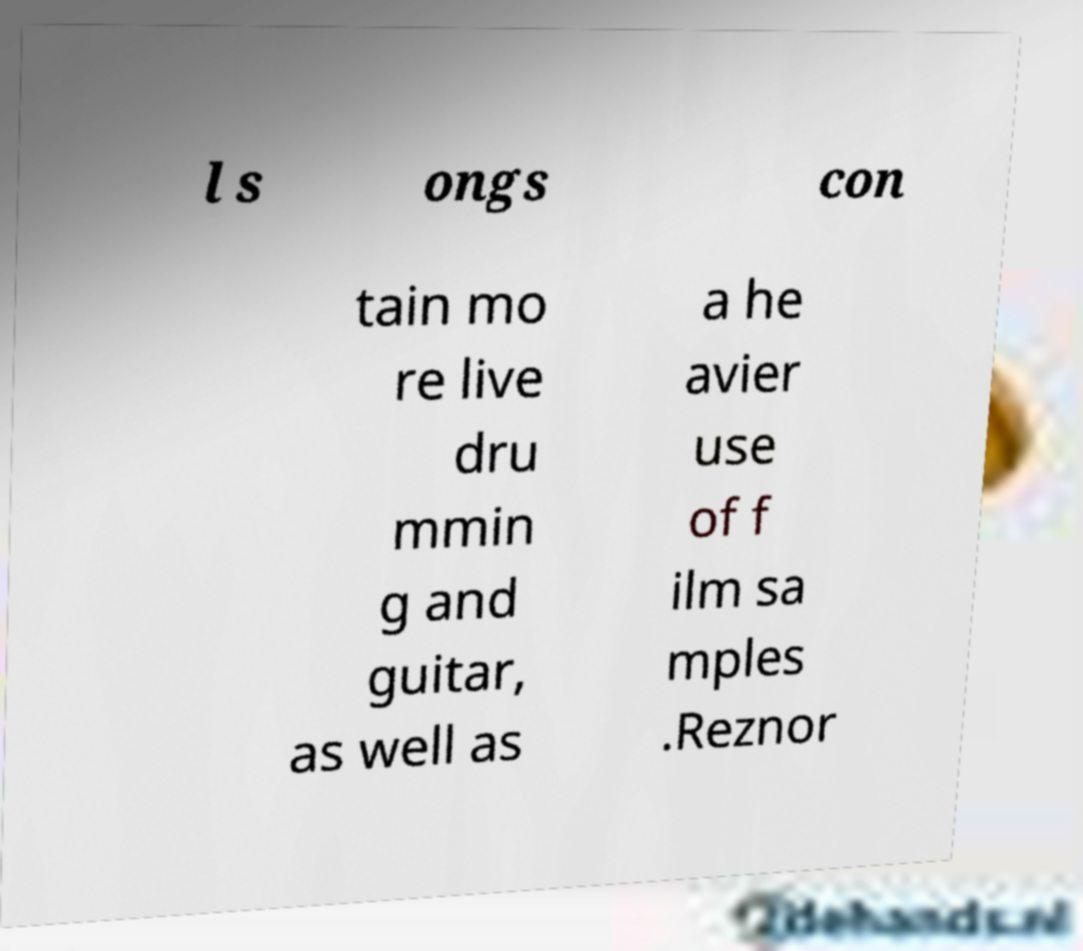Please identify and transcribe the text found in this image. l s ongs con tain mo re live dru mmin g and guitar, as well as a he avier use of f ilm sa mples .Reznor 